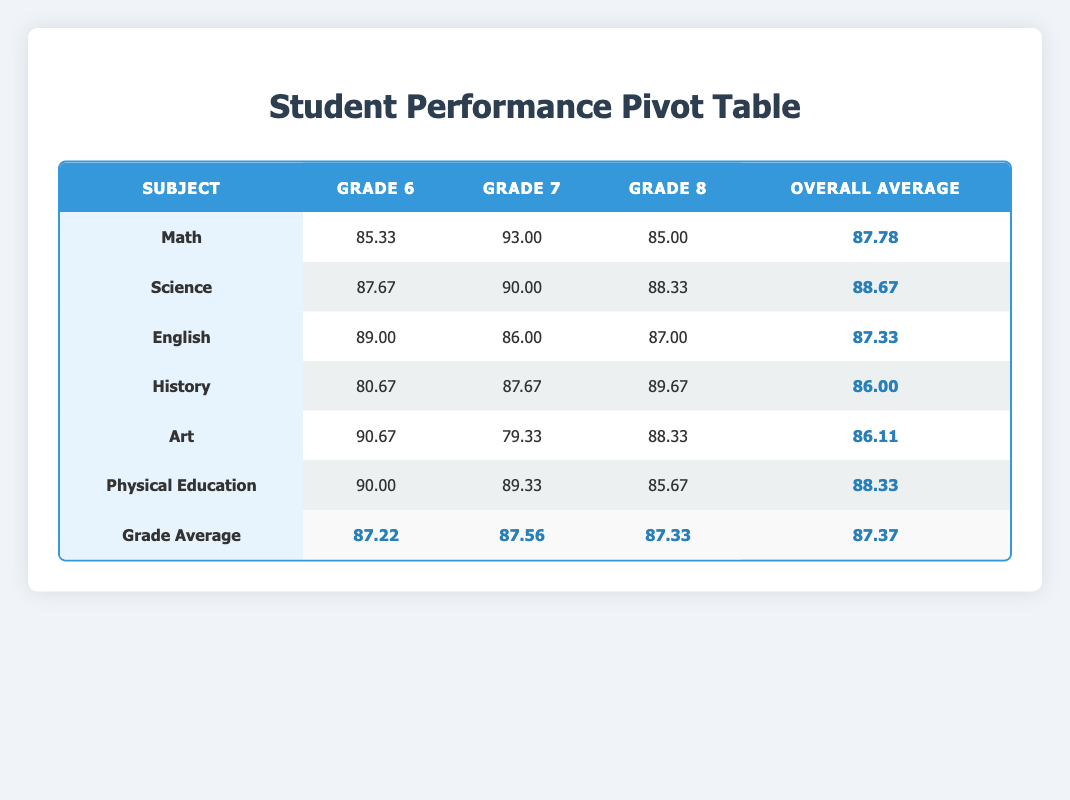What is the highest average score in math across all grades? The average scores for math by grade are 85.33 for Grade 6, 93.00 for Grade 7, and 85.00 for Grade 8. The highest average score is 93.00 in Grade 7.
Answer: 93.00 Which subject has the lowest overall average score? The overall average scores for the subjects are: Math 87.78, Science 88.67, English 87.33, History 86.00, Art 86.11, and Physical Education 88.33. The lowest is History with an average of 86.00.
Answer: History What is the difference between the average scores in Physical Education for Grade 6 and Grade 8? The average score for Physical Education in Grade 6 is 90.00 and in Grade 8 is 85.67. The difference is 90.00 - 85.67 = 4.33.
Answer: 4.33 Is the average score in Science for Grade 7 higher than the average score in English for the same grade? The average score in Science for Grade 7 is 90.00, and the average score in English for Grade 7 is 86.00. Since 90.00 is greater than 86.00, the statement is true.
Answer: Yes What is the overall average score for Grade 6 students? The average scores for Grade 6 in each subject are as follows: Math 85.33, Science 87.67, English 89.00, History 80.67, Art 90.67, and Physical Education 90.00. To find the overall average, sum these and divide by 6: (85.33 + 87.67 + 89.00 + 80.67 + 90.67 + 90.00) / 6 = 87.22.
Answer: 87.22 Which grade has the highest average score in Art? The average scores in Art for each grade are: Grade 6 is 90.67, Grade 7 is 79.33, and Grade 8 is 88.33. The highest is in Grade 6 with a score of 90.67.
Answer: Grade 6 What is the average score in English for Grade 8 students? The average score for English in Grade 8 is given in the table as 87.00.
Answer: 87.00 Is the average score for Science in Grade 6 greater than 86? The average score for Science in Grade 6 is 87.67, which is indeed greater than 86, making the statement true.
Answer: Yes 